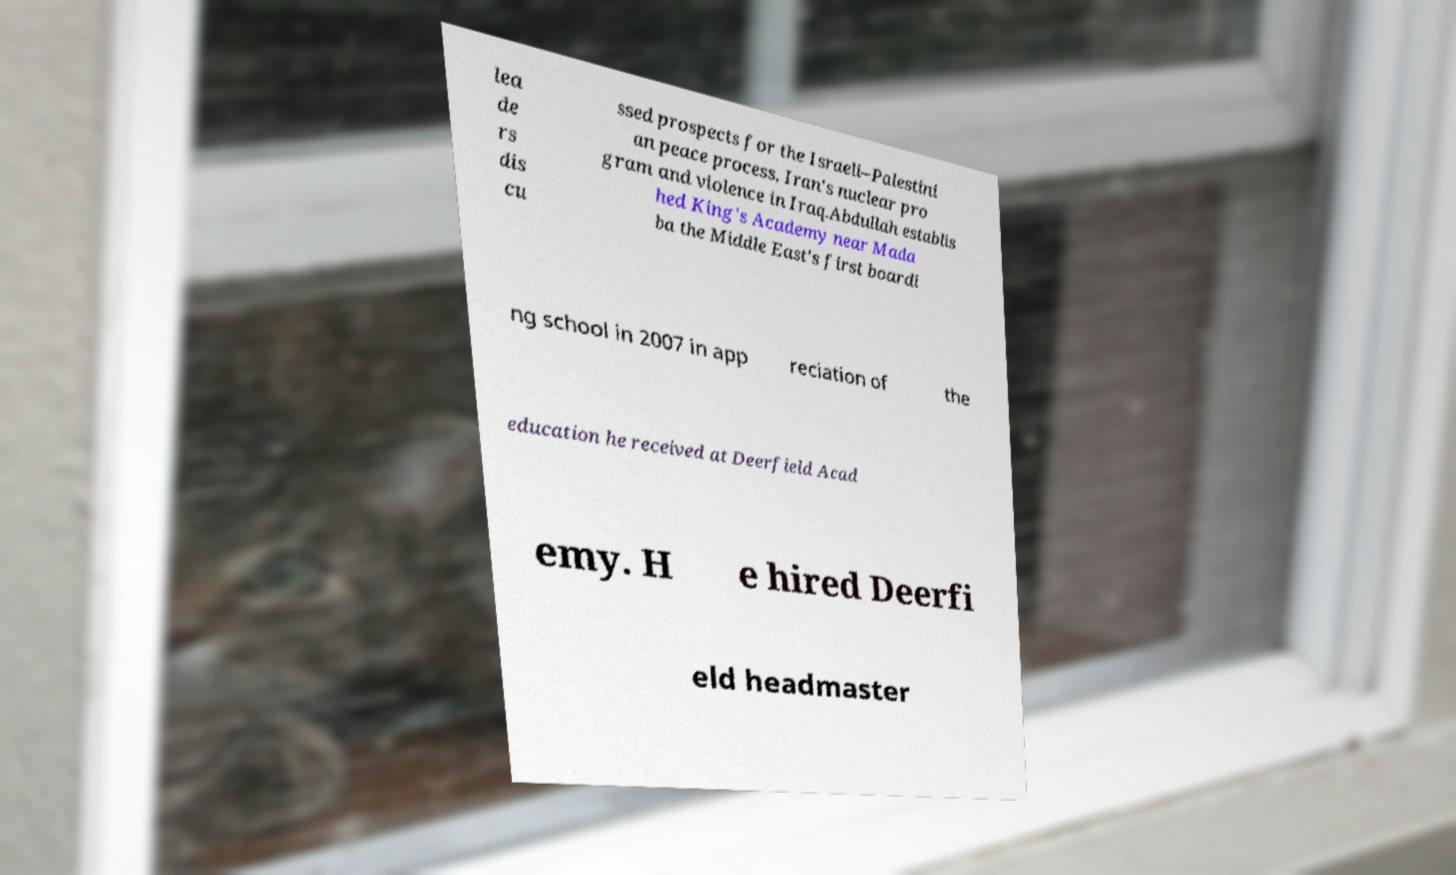Can you read and provide the text displayed in the image?This photo seems to have some interesting text. Can you extract and type it out for me? lea de rs dis cu ssed prospects for the Israeli–Palestini an peace process, Iran's nuclear pro gram and violence in Iraq.Abdullah establis hed King's Academy near Mada ba the Middle East's first boardi ng school in 2007 in app reciation of the education he received at Deerfield Acad emy. H e hired Deerfi eld headmaster 